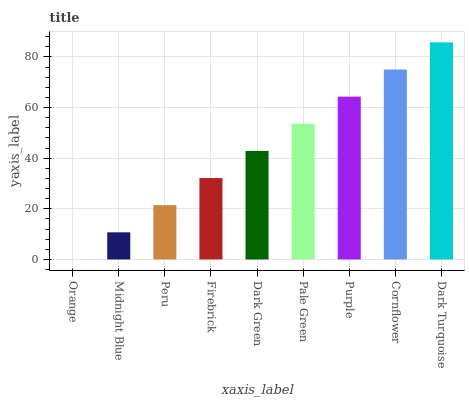Is Orange the minimum?
Answer yes or no. Yes. Is Dark Turquoise the maximum?
Answer yes or no. Yes. Is Midnight Blue the minimum?
Answer yes or no. No. Is Midnight Blue the maximum?
Answer yes or no. No. Is Midnight Blue greater than Orange?
Answer yes or no. Yes. Is Orange less than Midnight Blue?
Answer yes or no. Yes. Is Orange greater than Midnight Blue?
Answer yes or no. No. Is Midnight Blue less than Orange?
Answer yes or no. No. Is Dark Green the high median?
Answer yes or no. Yes. Is Dark Green the low median?
Answer yes or no. Yes. Is Dark Turquoise the high median?
Answer yes or no. No. Is Midnight Blue the low median?
Answer yes or no. No. 